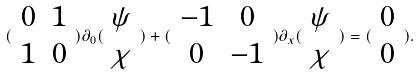<formula> <loc_0><loc_0><loc_500><loc_500>( \begin{array} { c c } 0 & 1 \\ 1 & 0 \end{array} ) \partial _ { 0 } ( \begin{array} { c } \psi \\ \chi \end{array} ) + ( \begin{array} { c c } - 1 & 0 \\ 0 & - 1 \end{array} ) \partial _ { x } ( \begin{array} { c } \psi \\ \chi \end{array} ) = ( \begin{array} { c } 0 \\ 0 \end{array} ) .</formula> 